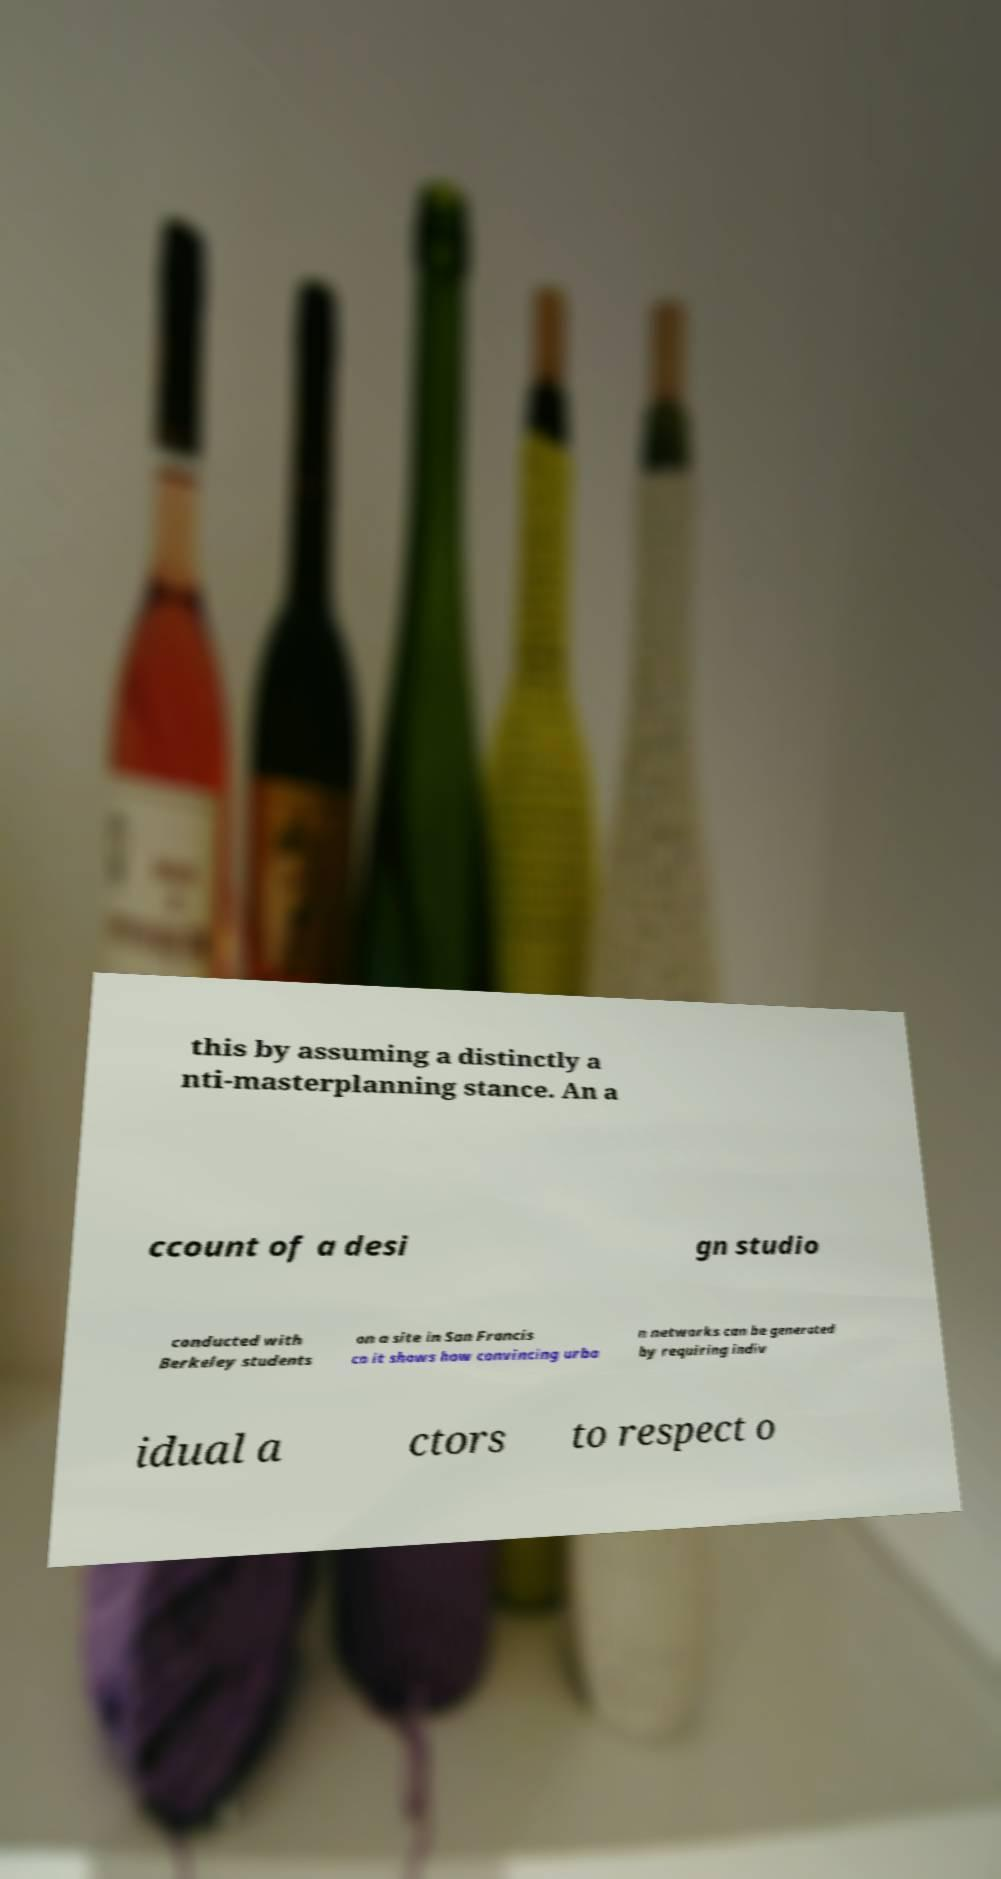For documentation purposes, I need the text within this image transcribed. Could you provide that? this by assuming a distinctly a nti-masterplanning stance. An a ccount of a desi gn studio conducted with Berkeley students on a site in San Francis co it shows how convincing urba n networks can be generated by requiring indiv idual a ctors to respect o 